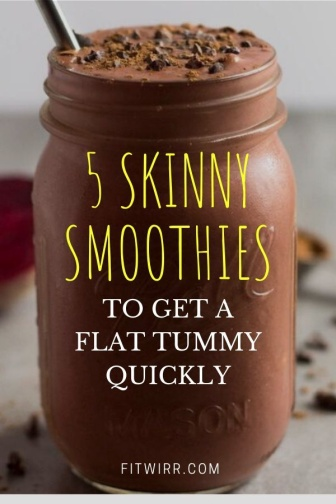Explain the visual content of the image in great detail. The image captures a delightful scene of a chocolate smoothie in a mason jar, which is placed on a gray countertop. The jar, filled to the brim with the smoothie, has a metal straw inserted into it, ready for someone to take a sip. Scattered around the jar on the countertop are chocolate chips, adding a touch of indulgence to the scene. A red napkin lies casually nearby, adding a pop of color to the otherwise neutral palette.

Overlaying the image is a bold, yellow text that reads "5 SKINNY SMOOTHIES TO GET A FLAT TUMMY QUICKLY". The word "SKINNY" is emphasized with a larger font size, drawing attention to the potential health benefits of the smoothies. At the bottom of the image, there's a small white text that credits "fitwirr.com", possibly the source of the smoothie recipe or the image itself. The entire scene suggests a focus on health, fitness, and delicious ways to achieve them. 